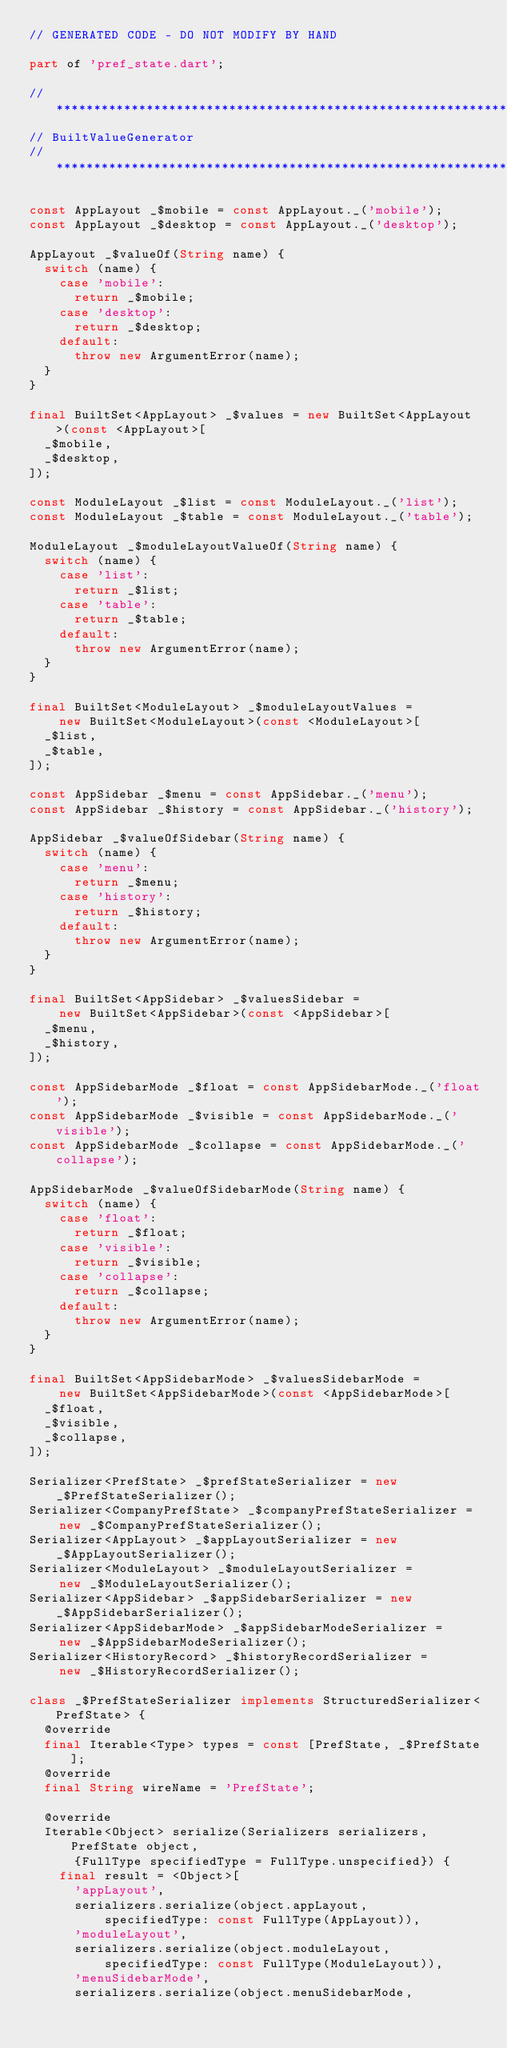<code> <loc_0><loc_0><loc_500><loc_500><_Dart_>// GENERATED CODE - DO NOT MODIFY BY HAND

part of 'pref_state.dart';

// **************************************************************************
// BuiltValueGenerator
// **************************************************************************

const AppLayout _$mobile = const AppLayout._('mobile');
const AppLayout _$desktop = const AppLayout._('desktop');

AppLayout _$valueOf(String name) {
  switch (name) {
    case 'mobile':
      return _$mobile;
    case 'desktop':
      return _$desktop;
    default:
      throw new ArgumentError(name);
  }
}

final BuiltSet<AppLayout> _$values = new BuiltSet<AppLayout>(const <AppLayout>[
  _$mobile,
  _$desktop,
]);

const ModuleLayout _$list = const ModuleLayout._('list');
const ModuleLayout _$table = const ModuleLayout._('table');

ModuleLayout _$moduleLayoutValueOf(String name) {
  switch (name) {
    case 'list':
      return _$list;
    case 'table':
      return _$table;
    default:
      throw new ArgumentError(name);
  }
}

final BuiltSet<ModuleLayout> _$moduleLayoutValues =
    new BuiltSet<ModuleLayout>(const <ModuleLayout>[
  _$list,
  _$table,
]);

const AppSidebar _$menu = const AppSidebar._('menu');
const AppSidebar _$history = const AppSidebar._('history');

AppSidebar _$valueOfSidebar(String name) {
  switch (name) {
    case 'menu':
      return _$menu;
    case 'history':
      return _$history;
    default:
      throw new ArgumentError(name);
  }
}

final BuiltSet<AppSidebar> _$valuesSidebar =
    new BuiltSet<AppSidebar>(const <AppSidebar>[
  _$menu,
  _$history,
]);

const AppSidebarMode _$float = const AppSidebarMode._('float');
const AppSidebarMode _$visible = const AppSidebarMode._('visible');
const AppSidebarMode _$collapse = const AppSidebarMode._('collapse');

AppSidebarMode _$valueOfSidebarMode(String name) {
  switch (name) {
    case 'float':
      return _$float;
    case 'visible':
      return _$visible;
    case 'collapse':
      return _$collapse;
    default:
      throw new ArgumentError(name);
  }
}

final BuiltSet<AppSidebarMode> _$valuesSidebarMode =
    new BuiltSet<AppSidebarMode>(const <AppSidebarMode>[
  _$float,
  _$visible,
  _$collapse,
]);

Serializer<PrefState> _$prefStateSerializer = new _$PrefStateSerializer();
Serializer<CompanyPrefState> _$companyPrefStateSerializer =
    new _$CompanyPrefStateSerializer();
Serializer<AppLayout> _$appLayoutSerializer = new _$AppLayoutSerializer();
Serializer<ModuleLayout> _$moduleLayoutSerializer =
    new _$ModuleLayoutSerializer();
Serializer<AppSidebar> _$appSidebarSerializer = new _$AppSidebarSerializer();
Serializer<AppSidebarMode> _$appSidebarModeSerializer =
    new _$AppSidebarModeSerializer();
Serializer<HistoryRecord> _$historyRecordSerializer =
    new _$HistoryRecordSerializer();

class _$PrefStateSerializer implements StructuredSerializer<PrefState> {
  @override
  final Iterable<Type> types = const [PrefState, _$PrefState];
  @override
  final String wireName = 'PrefState';

  @override
  Iterable<Object> serialize(Serializers serializers, PrefState object,
      {FullType specifiedType = FullType.unspecified}) {
    final result = <Object>[
      'appLayout',
      serializers.serialize(object.appLayout,
          specifiedType: const FullType(AppLayout)),
      'moduleLayout',
      serializers.serialize(object.moduleLayout,
          specifiedType: const FullType(ModuleLayout)),
      'menuSidebarMode',
      serializers.serialize(object.menuSidebarMode,</code> 